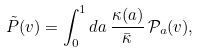Convert formula to latex. <formula><loc_0><loc_0><loc_500><loc_500>\tilde { P } ( v ) = \int _ { 0 } ^ { 1 } d a \, \frac { \kappa ( a ) } { \bar { \kappa } } \, \mathcal { P } _ { a } ( v ) ,</formula> 